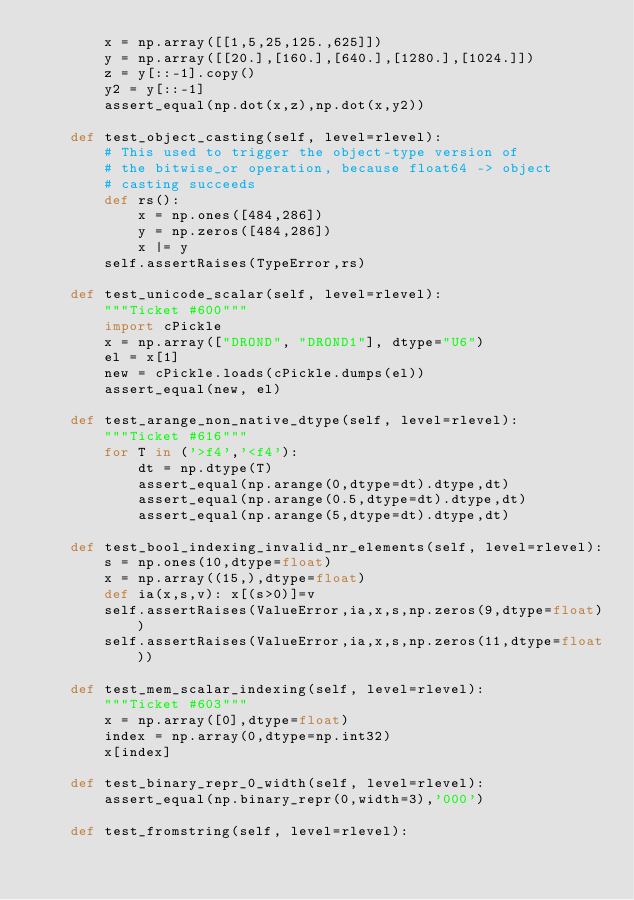<code> <loc_0><loc_0><loc_500><loc_500><_Python_>        x = np.array([[1,5,25,125.,625]])
        y = np.array([[20.],[160.],[640.],[1280.],[1024.]])
        z = y[::-1].copy()
        y2 = y[::-1]
        assert_equal(np.dot(x,z),np.dot(x,y2))

    def test_object_casting(self, level=rlevel):
        # This used to trigger the object-type version of
        # the bitwise_or operation, because float64 -> object
        # casting succeeds
        def rs():
            x = np.ones([484,286])
            y = np.zeros([484,286])
            x |= y
        self.assertRaises(TypeError,rs)

    def test_unicode_scalar(self, level=rlevel):
        """Ticket #600"""
        import cPickle
        x = np.array(["DROND", "DROND1"], dtype="U6")
        el = x[1]
        new = cPickle.loads(cPickle.dumps(el))
        assert_equal(new, el)

    def test_arange_non_native_dtype(self, level=rlevel):
        """Ticket #616"""
        for T in ('>f4','<f4'):
            dt = np.dtype(T)
            assert_equal(np.arange(0,dtype=dt).dtype,dt)
            assert_equal(np.arange(0.5,dtype=dt).dtype,dt)
            assert_equal(np.arange(5,dtype=dt).dtype,dt)

    def test_bool_indexing_invalid_nr_elements(self, level=rlevel):
        s = np.ones(10,dtype=float)
        x = np.array((15,),dtype=float)
        def ia(x,s,v): x[(s>0)]=v
        self.assertRaises(ValueError,ia,x,s,np.zeros(9,dtype=float))
        self.assertRaises(ValueError,ia,x,s,np.zeros(11,dtype=float))

    def test_mem_scalar_indexing(self, level=rlevel):
        """Ticket #603"""
        x = np.array([0],dtype=float)
        index = np.array(0,dtype=np.int32)
        x[index]

    def test_binary_repr_0_width(self, level=rlevel):
        assert_equal(np.binary_repr(0,width=3),'000')

    def test_fromstring(self, level=rlevel):</code> 